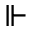Convert formula to latex. <formula><loc_0><loc_0><loc_500><loc_500>\ V d a s h</formula> 